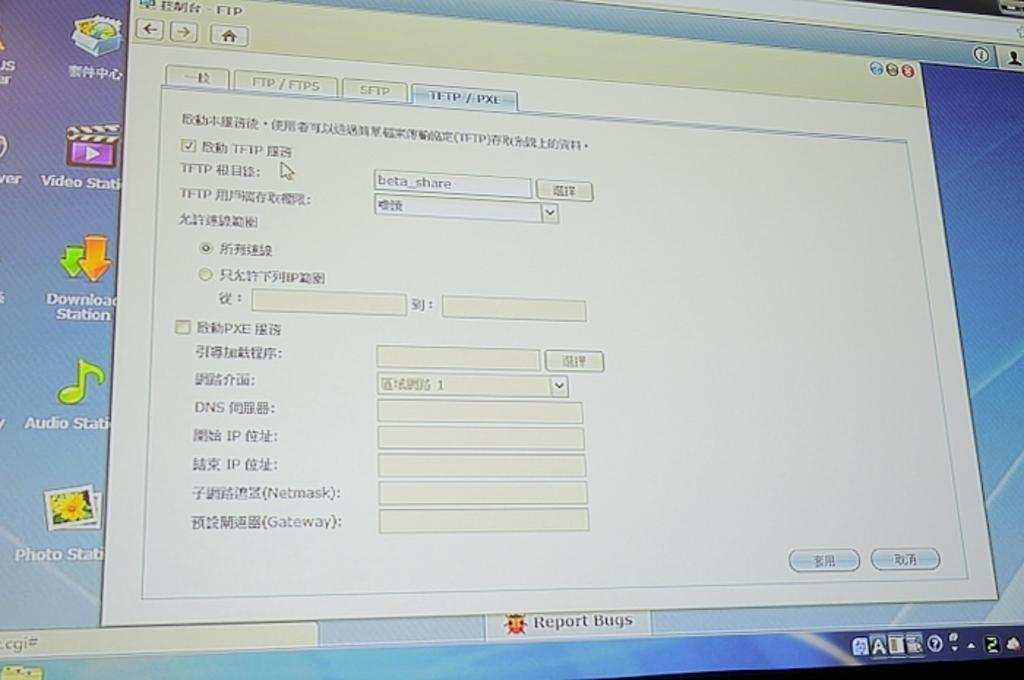Provide a one-sentence caption for the provided image. A computer screen shows several shortcut icons to programs such as photo, video, and download stations. 